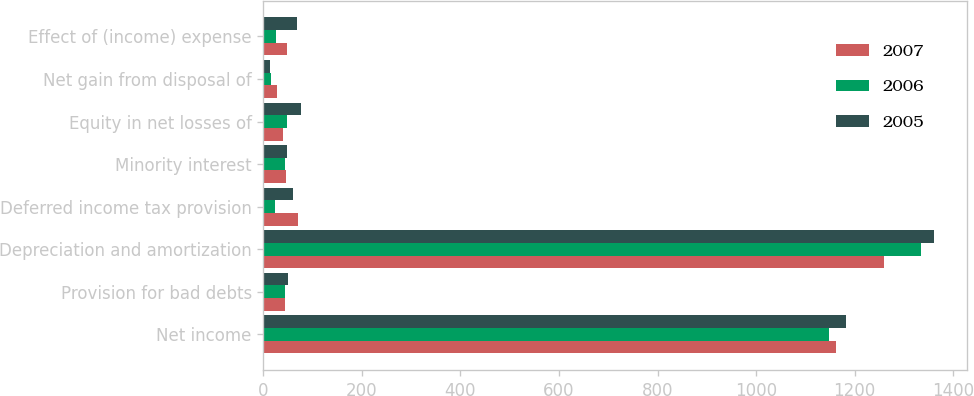Convert chart. <chart><loc_0><loc_0><loc_500><loc_500><stacked_bar_chart><ecel><fcel>Net income<fcel>Provision for bad debts<fcel>Depreciation and amortization<fcel>Deferred income tax provision<fcel>Minority interest<fcel>Equity in net losses of<fcel>Net gain from disposal of<fcel>Effect of (income) expense<nl><fcel>2007<fcel>1163<fcel>43<fcel>1259<fcel>70<fcel>46<fcel>39<fcel>27<fcel>47<nl><fcel>2006<fcel>1149<fcel>43<fcel>1334<fcel>23<fcel>44<fcel>47<fcel>15<fcel>25<nl><fcel>2005<fcel>1182<fcel>50<fcel>1361<fcel>61<fcel>48<fcel>76<fcel>14<fcel>68<nl></chart> 